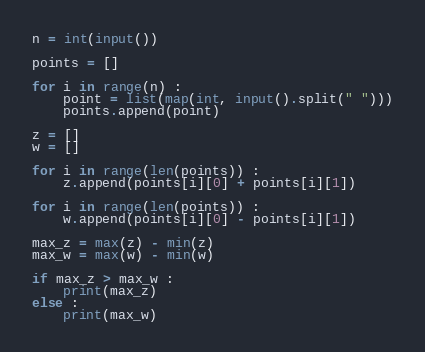<code> <loc_0><loc_0><loc_500><loc_500><_Python_>n = int(input())

points = []

for i in range(n) :
    point = list(map(int, input().split(" ")))
    points.append(point)

z = []
w = []

for i in range(len(points)) :
    z.append(points[i][0] + points[i][1])

for i in range(len(points)) :
    w.append(points[i][0] - points[i][1])

max_z = max(z) - min(z)
max_w = max(w) - min(w)

if max_z > max_w :
    print(max_z)
else :
    print(max_w)
</code> 